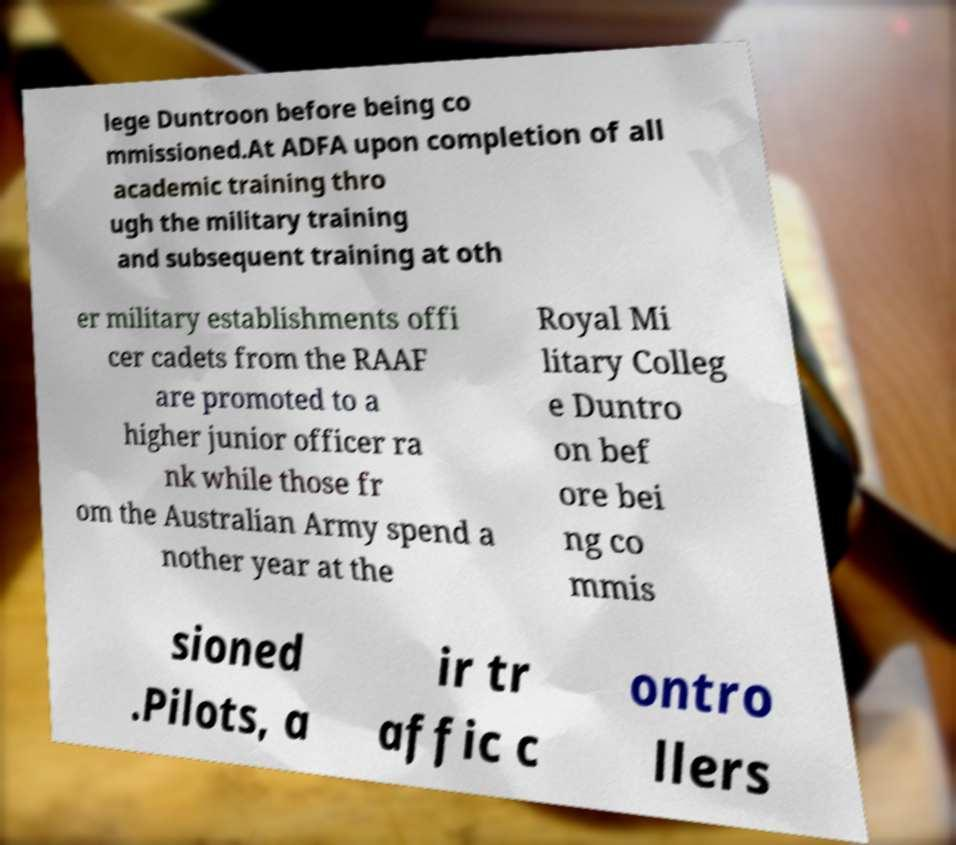Could you assist in decoding the text presented in this image and type it out clearly? lege Duntroon before being co mmissioned.At ADFA upon completion of all academic training thro ugh the military training and subsequent training at oth er military establishments offi cer cadets from the RAAF are promoted to a higher junior officer ra nk while those fr om the Australian Army spend a nother year at the Royal Mi litary Colleg e Duntro on bef ore bei ng co mmis sioned .Pilots, a ir tr affic c ontro llers 